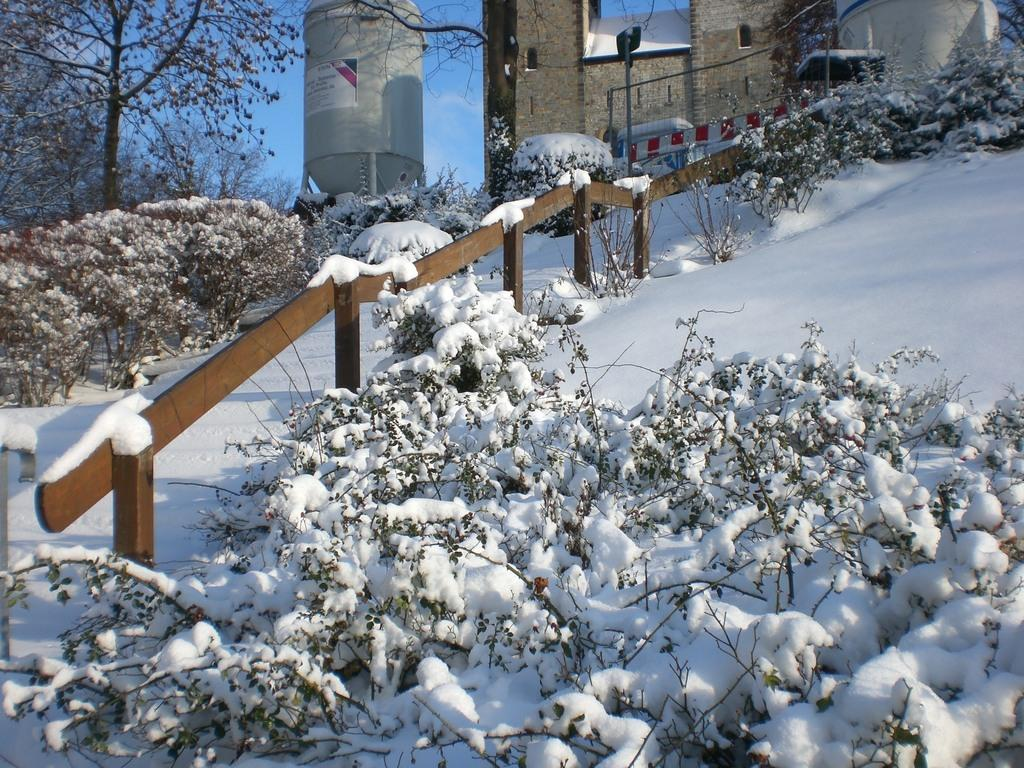What is the primary feature of the landscape in the image? The image shows an area covered with thick snow. What type of terrain can be seen in the image? There is a slope in the image. What is visible above the slope? There is some architecture visible above the slope. What type of vegetation is present in the image? There is a tree on the left side of the image. How many tents are set up on the slope in the image? There are no tents visible in the image; it shows an area covered with thick snow and a slope with architecture above it. What type of wing is shown flying over the tree in the image? There are no wings or flying objects present in the image; it only shows an area covered with thick snow, a slope, architecture, and a tree. 